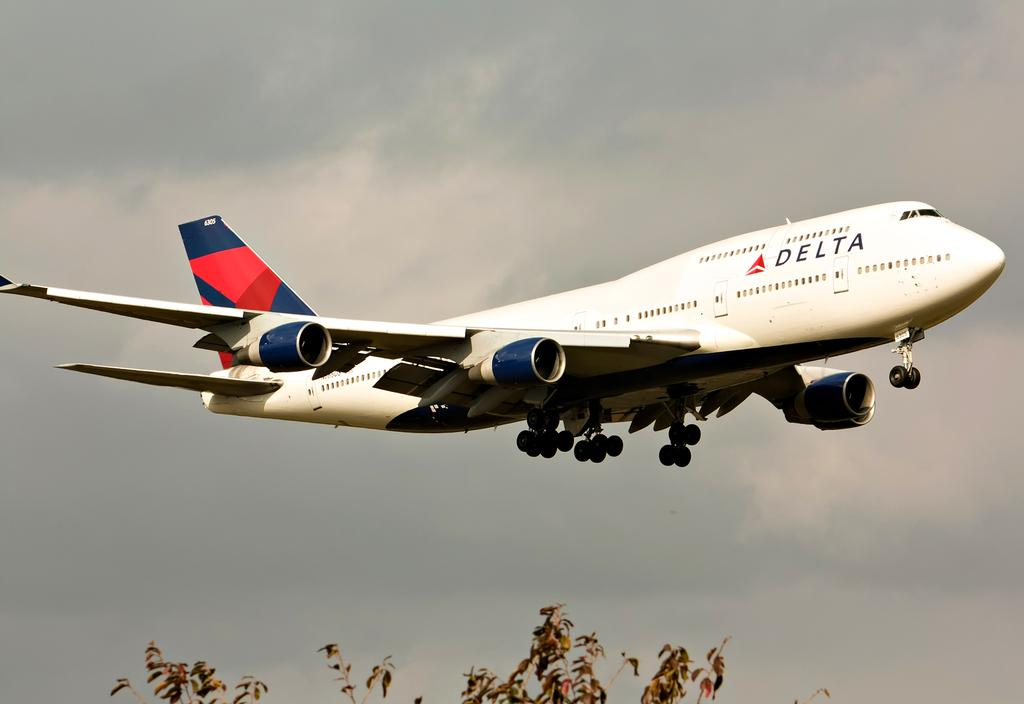Provide a one-sentence caption for the provided image. The Delta Plane is flying in a partly cloudy sky. 